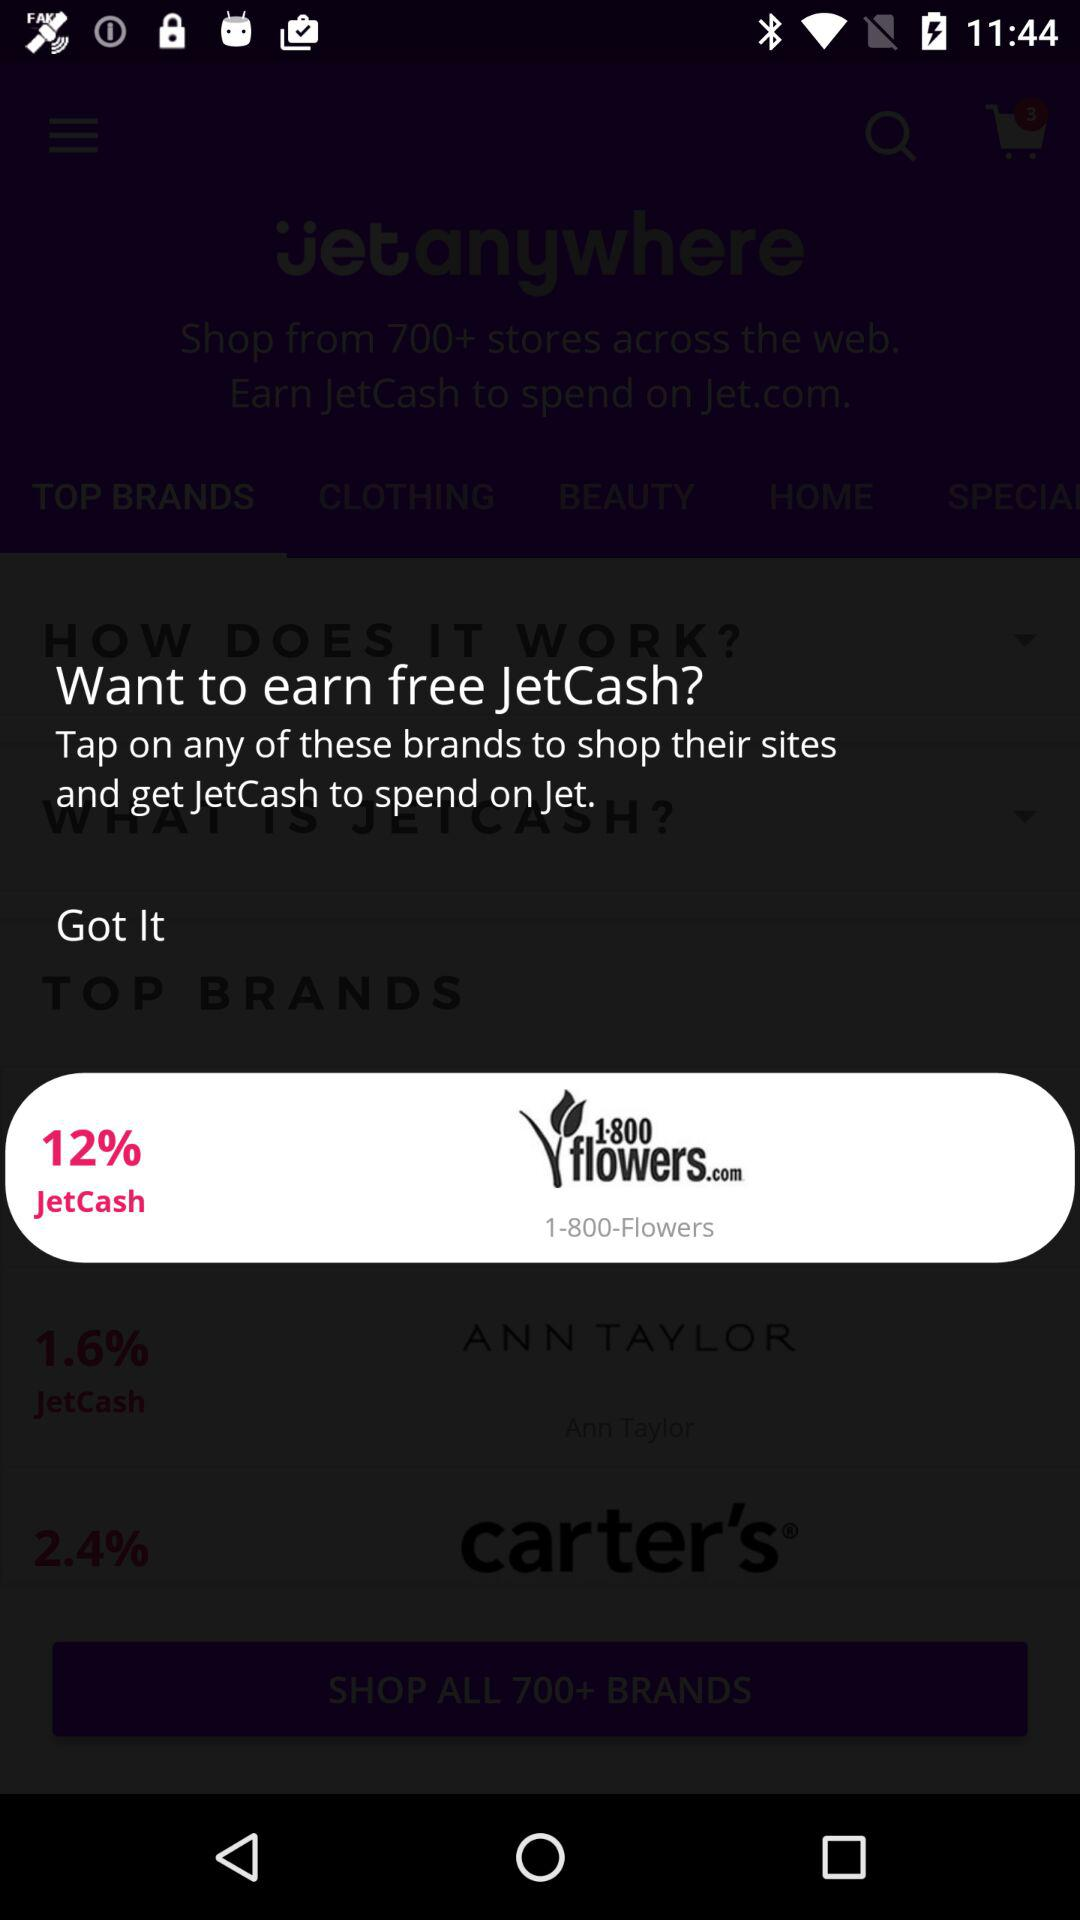What is the percentage of jetCash in "1-800 flowers.com"? The percentage of jetCash in "1-800 flowers.com" is 12. 